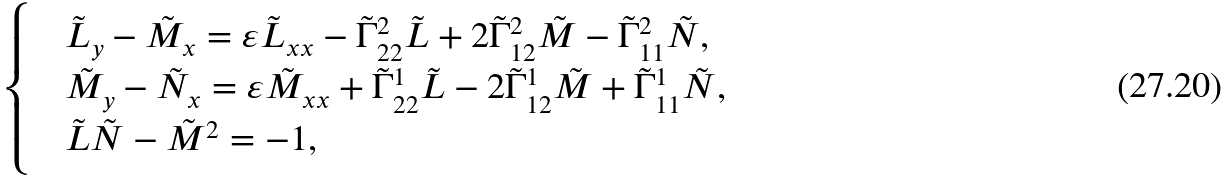<formula> <loc_0><loc_0><loc_500><loc_500>\begin{cases} & \tilde { L } _ { y } - \tilde { M } _ { x } = \varepsilon \tilde { L } _ { x x } - \tilde { \Gamma } ^ { 2 } _ { 2 2 } \tilde { L } + 2 \tilde { \Gamma } ^ { 2 } _ { 1 2 } \tilde { M } - \tilde { \Gamma } ^ { 2 } _ { 1 1 } \tilde { N } , \\ & \tilde { M } _ { y } - \tilde { N } _ { x } = \varepsilon \tilde { M } _ { x x } + \tilde { \Gamma } ^ { 1 } _ { 2 2 } \tilde { L } - 2 \tilde { \Gamma } ^ { 1 } _ { 1 2 } \tilde { M } + \tilde { \Gamma } ^ { 1 } _ { 1 1 } \tilde { N } , \\ & \tilde { L } \tilde { N } - \tilde { M } ^ { 2 } = - 1 , \end{cases}</formula> 